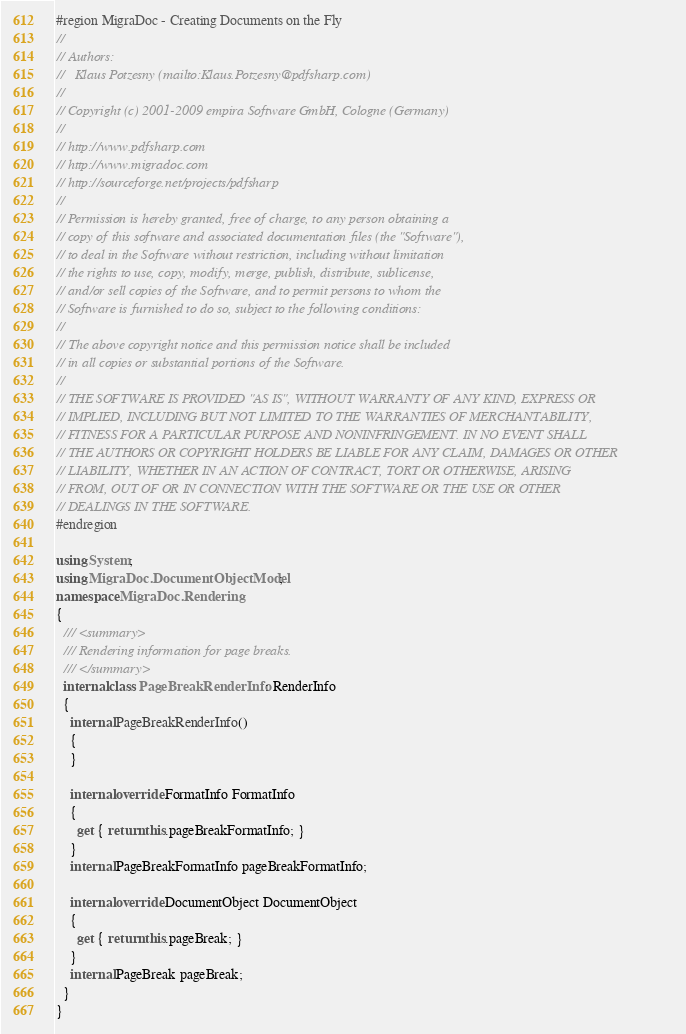Convert code to text. <code><loc_0><loc_0><loc_500><loc_500><_C#_>#region MigraDoc - Creating Documents on the Fly
//
// Authors:
//   Klaus Potzesny (mailto:Klaus.Potzesny@pdfsharp.com)
//
// Copyright (c) 2001-2009 empira Software GmbH, Cologne (Germany)
//
// http://www.pdfsharp.com
// http://www.migradoc.com
// http://sourceforge.net/projects/pdfsharp
//
// Permission is hereby granted, free of charge, to any person obtaining a
// copy of this software and associated documentation files (the "Software"),
// to deal in the Software without restriction, including without limitation
// the rights to use, copy, modify, merge, publish, distribute, sublicense,
// and/or sell copies of the Software, and to permit persons to whom the
// Software is furnished to do so, subject to the following conditions:
//
// The above copyright notice and this permission notice shall be included
// in all copies or substantial portions of the Software.
//
// THE SOFTWARE IS PROVIDED "AS IS", WITHOUT WARRANTY OF ANY KIND, EXPRESS OR
// IMPLIED, INCLUDING BUT NOT LIMITED TO THE WARRANTIES OF MERCHANTABILITY,
// FITNESS FOR A PARTICULAR PURPOSE AND NONINFRINGEMENT. IN NO EVENT SHALL
// THE AUTHORS OR COPYRIGHT HOLDERS BE LIABLE FOR ANY CLAIM, DAMAGES OR OTHER
// LIABILITY, WHETHER IN AN ACTION OF CONTRACT, TORT OR OTHERWISE, ARISING
// FROM, OUT OF OR IN CONNECTION WITH THE SOFTWARE OR THE USE OR OTHER 
// DEALINGS IN THE SOFTWARE.
#endregion

using System;
using MigraDoc.DocumentObjectModel;
namespace MigraDoc.Rendering
{
  /// <summary>
  /// Rendering information for page breaks.
  /// </summary>
  internal class PageBreakRenderInfo : RenderInfo
  {
    internal PageBreakRenderInfo()
    {
    }

    internal override FormatInfo FormatInfo
    {
      get { return this.pageBreakFormatInfo; }
    }
    internal PageBreakFormatInfo pageBreakFormatInfo;

    internal override DocumentObject DocumentObject
    {
      get { return this.pageBreak; }
    }
    internal PageBreak pageBreak;
  }
}
</code> 